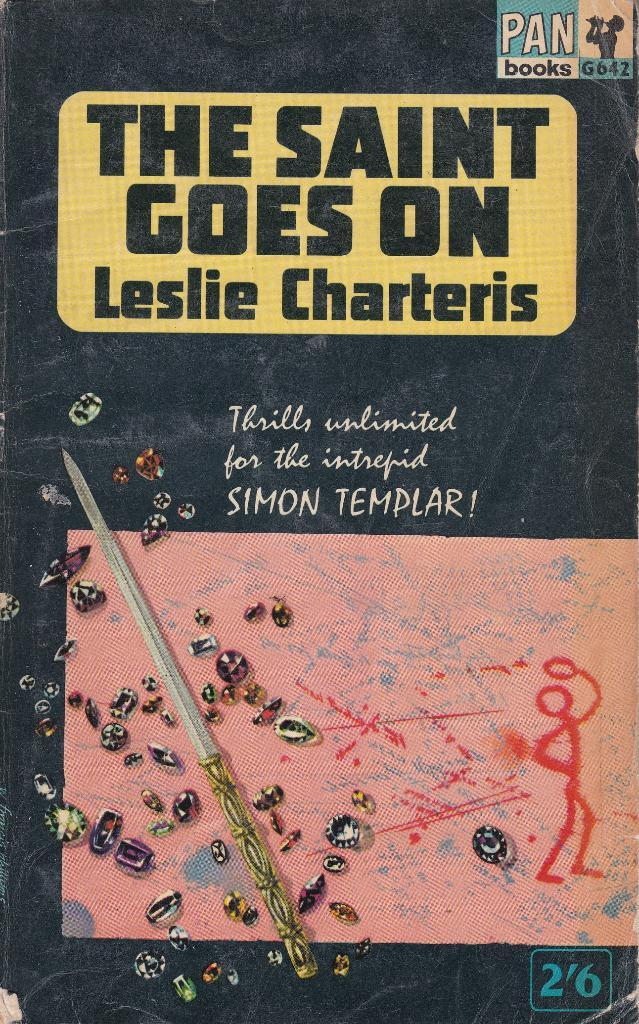<image>
Create a compact narrative representing the image presented. A paperback featuring the Simon Templar character claims to offer thrills unlimited. 